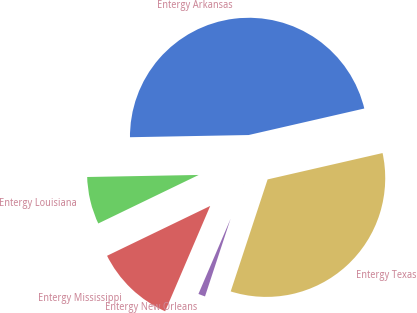Convert chart to OTSL. <chart><loc_0><loc_0><loc_500><loc_500><pie_chart><fcel>Entergy Arkansas<fcel>Entergy Louisiana<fcel>Entergy Mississippi<fcel>Entergy New Orleans<fcel>Entergy Texas<nl><fcel>46.7%<fcel>6.87%<fcel>11.4%<fcel>1.37%<fcel>33.65%<nl></chart> 